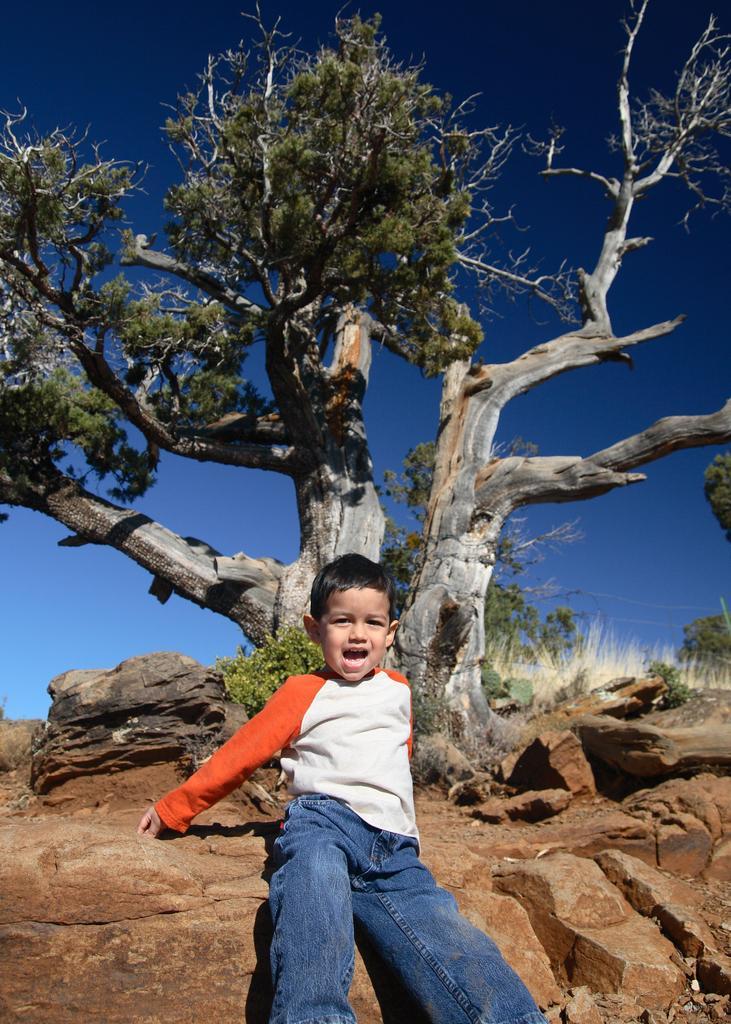Please provide a concise description of this image. In the picture we can see a boy leaning to the rock surface and opening his mouth and in the background, we can see a tree and some plant near to it and in the background we can see some grass plants and sky which is blue in color. 